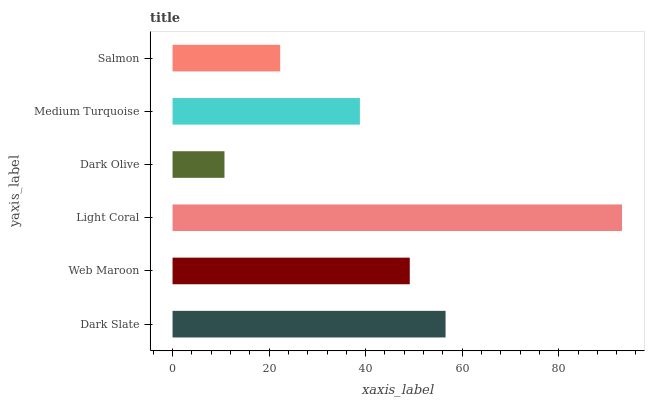Is Dark Olive the minimum?
Answer yes or no. Yes. Is Light Coral the maximum?
Answer yes or no. Yes. Is Web Maroon the minimum?
Answer yes or no. No. Is Web Maroon the maximum?
Answer yes or no. No. Is Dark Slate greater than Web Maroon?
Answer yes or no. Yes. Is Web Maroon less than Dark Slate?
Answer yes or no. Yes. Is Web Maroon greater than Dark Slate?
Answer yes or no. No. Is Dark Slate less than Web Maroon?
Answer yes or no. No. Is Web Maroon the high median?
Answer yes or no. Yes. Is Medium Turquoise the low median?
Answer yes or no. Yes. Is Salmon the high median?
Answer yes or no. No. Is Light Coral the low median?
Answer yes or no. No. 